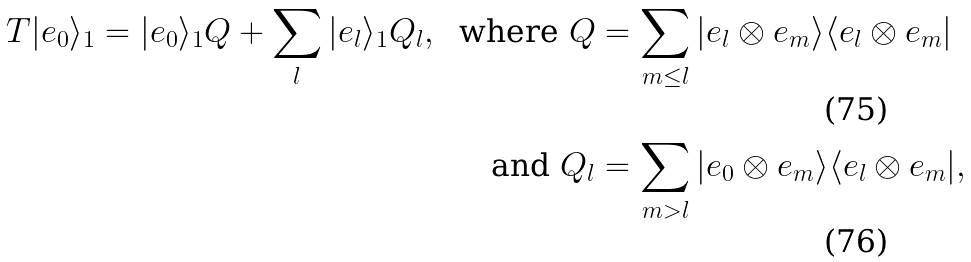Convert formula to latex. <formula><loc_0><loc_0><loc_500><loc_500>T | e _ { 0 } \rangle _ { 1 } = | e _ { 0 } \rangle _ { 1 } Q + \sum _ { l } | e _ { l } \rangle _ { 1 } Q _ { l } , \ \text { where   } Q & = \sum _ { m \leq l } | e _ { l } \otimes e _ { m } \rangle \langle e _ { l } \otimes e _ { m } | \\ \text { and } Q _ { l } & = \sum _ { m > l } | e _ { 0 } \otimes e _ { m } \rangle \langle e _ { l } \otimes e _ { m } | ,</formula> 